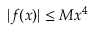Convert formula to latex. <formula><loc_0><loc_0><loc_500><loc_500>| f ( x ) | \leq M x ^ { 4 }</formula> 